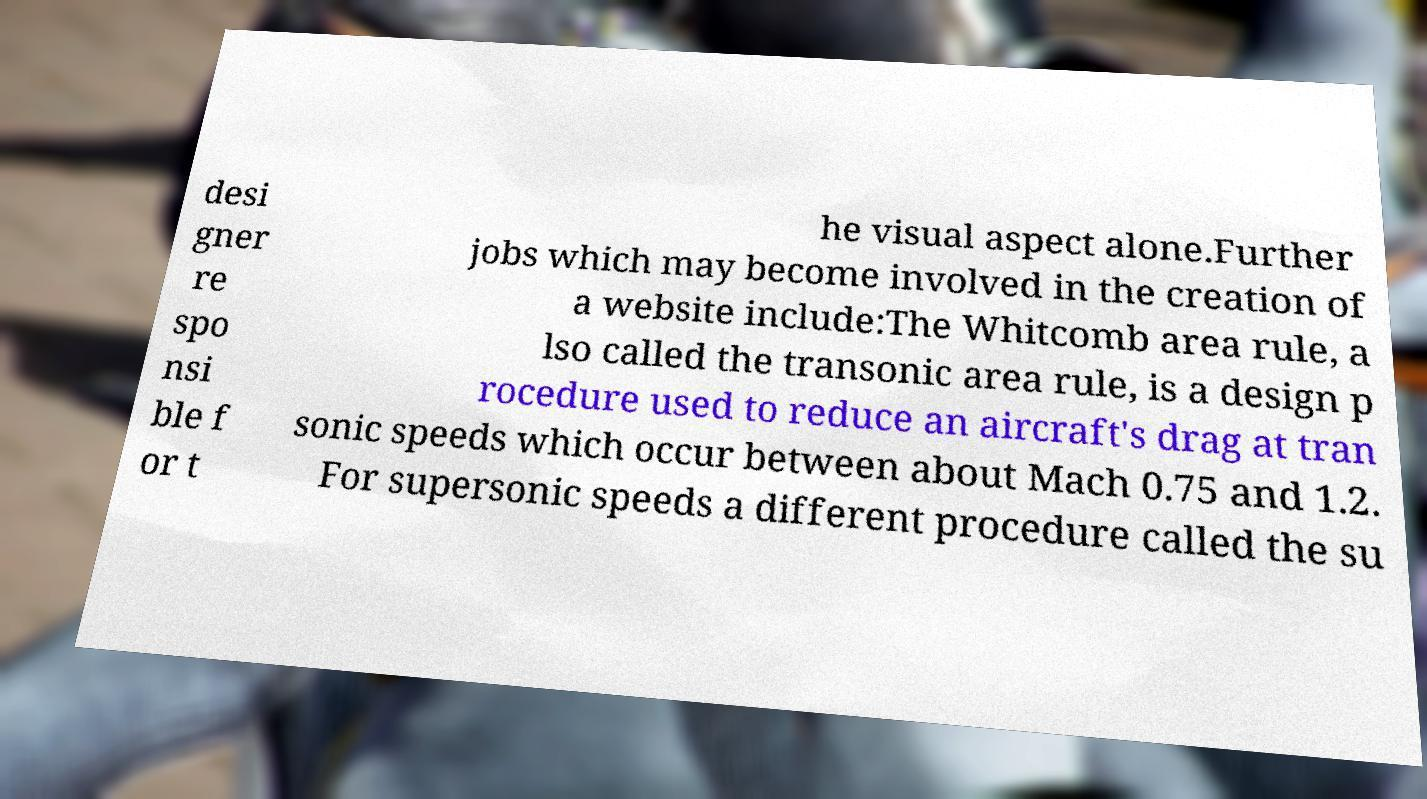Could you extract and type out the text from this image? desi gner re spo nsi ble f or t he visual aspect alone.Further jobs which may become involved in the creation of a website include:The Whitcomb area rule, a lso called the transonic area rule, is a design p rocedure used to reduce an aircraft's drag at tran sonic speeds which occur between about Mach 0.75 and 1.2. For supersonic speeds a different procedure called the su 